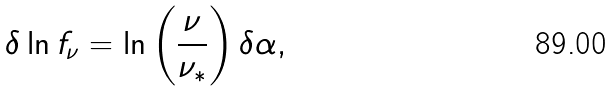<formula> <loc_0><loc_0><loc_500><loc_500>\delta \ln f _ { \nu } = \ln \left ( \frac { \nu } { \nu _ { * } } \right ) \delta \alpha ,</formula> 